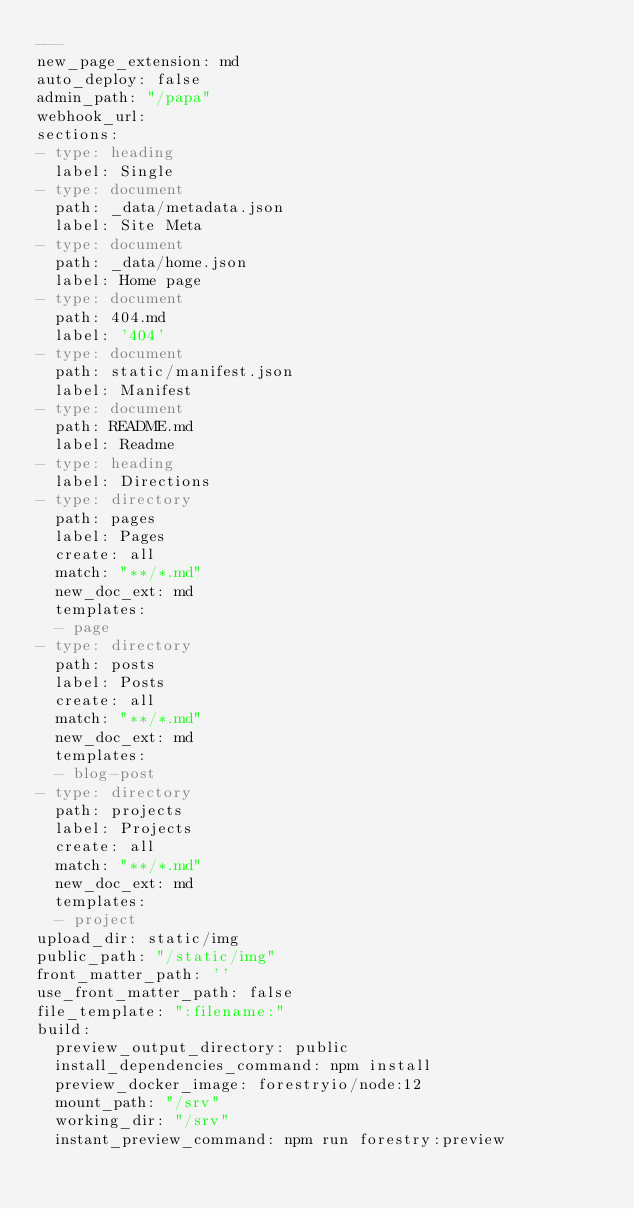<code> <loc_0><loc_0><loc_500><loc_500><_YAML_>---
new_page_extension: md
auto_deploy: false
admin_path: "/papa"
webhook_url: 
sections:
- type: heading
  label: Single
- type: document
  path: _data/metadata.json
  label: Site Meta
- type: document
  path: _data/home.json
  label: Home page
- type: document
  path: 404.md
  label: '404'
- type: document
  path: static/manifest.json
  label: Manifest
- type: document
  path: README.md
  label: Readme
- type: heading
  label: Directions
- type: directory
  path: pages
  label: Pages
  create: all
  match: "**/*.md"
  new_doc_ext: md
  templates:
  - page
- type: directory
  path: posts
  label: Posts
  create: all
  match: "**/*.md"
  new_doc_ext: md
  templates:
  - blog-post
- type: directory
  path: projects
  label: Projects
  create: all
  match: "**/*.md"
  new_doc_ext: md
  templates:
  - project
upload_dir: static/img
public_path: "/static/img"
front_matter_path: ''
use_front_matter_path: false
file_template: ":filename:"
build:
  preview_output_directory: public
  install_dependencies_command: npm install
  preview_docker_image: forestryio/node:12
  mount_path: "/srv"
  working_dir: "/srv"
  instant_preview_command: npm run forestry:preview
</code> 